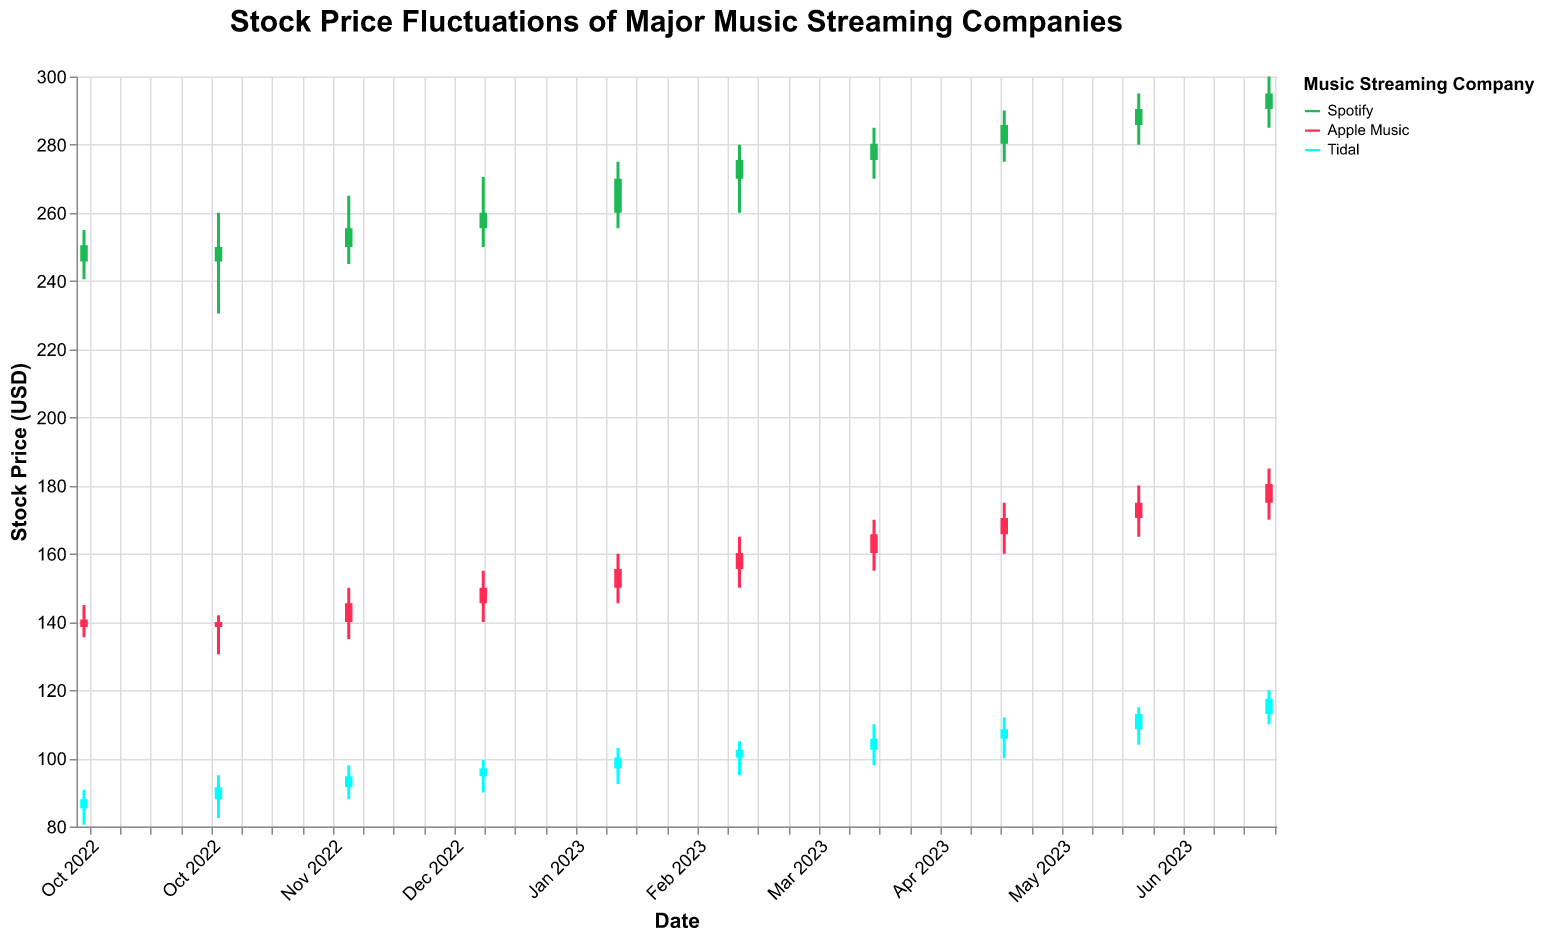What's the highest stock price recorded for Spotify over the past year? The highest stock price recorded for Spotify can be observed by looking at the "High" values in the candlestick chart. Referring to the plot, the highest price was $300.00 on July 1, 2023.
Answer: $300.00 How did the stock price trend for Tidal from January 2023 to July 2023? To answer this, examine the trend in the "Close" values for Tidal. From January 2023 to July 2023, the close prices are: $97.00, $100.25, $102.50, $105.75, $108.50, $113.00, and $117.50. This shows a steady upward trend.
Answer: Upward trend Which company had the highest closing price in February 2023? To determine this, compare the closing prices of all three companies in February 2023. Spotify's closing price is $270.00, Apple Music's is $155.50, and Tidal's is $100.25. Therefore, Spotify had the highest closing price.
Answer: Spotify What is the average closing price for Apple Music from October 2022 to July 2023? First, sum the closing prices for Apple Music from October 2022 to July 2023: $138.50, $140.00, $145.50, $150.00, $155.50, $160.25, $165.75, $170.50, $175.00, and $180.50. The total is $1581.50. There are 10 months, so the average is $1581.50 / 10 = $158.15.
Answer: $158.15 Compare the volume of trades for Spotify and Apple Music in May 2023. Which had a higher volume? For May 2023, examine the "Volume" values; Spotify's volume is 8600000, and Apple Music's volume is 7400000. Therefore, Spotify had a higher trading volume.
Answer: Spotify What is the percent increase in Tidal's closing price from October 2022 to July 2023? Tidal's closing price in October 2022 is $88.00, and in July 2023 it is $117.50. Percent increase = [(117.50 - 88.00) / 88.00] * 100 = (29.50 / 88.00) * 100 ≈ 33.52%.
Answer: 33.52% Did any company experience a decline in their closing price in any month? To find this, look at the trends for each company's closing prices on the candlestick chart. All companies showed an upward trend each month. Therefore, no company experienced a decline in any month.
Answer: No Which company has the most consistent stock price based on the candlestick height variation? Consistency in stock price can be inferred from the height of the candlestick which shows the difference between "High" and "Low". Tidal's candlestick heights seem relatively uniform compared to Spotify and Apple Music, so Tidal has the most consistent stock price.
Answer: Tidal What's the difference between the highest and lowest closing prices for Apple Music over the past year? The highest closing price for Apple Music is $180.50 (July 2023), and the lowest is $138.50 (October 2022). Difference = 180.50 - 138.50 = $42.00.
Answer: $42.00 